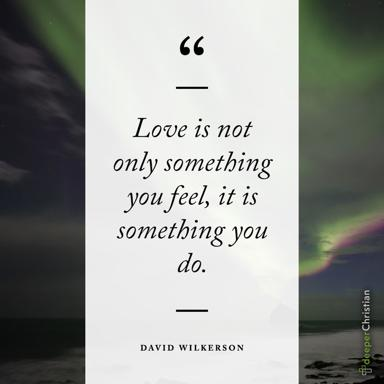Why might the choice of a minimalist design be significant for this type of quote? The minimalist design focuses the viewer's attention solely on the quote, ensuring that the words stand out without distraction. This design choice underscores the purity and clarity of the message about love being an action, suggesting that this concept is straightforward and unadorned, much like the presentation itself. 